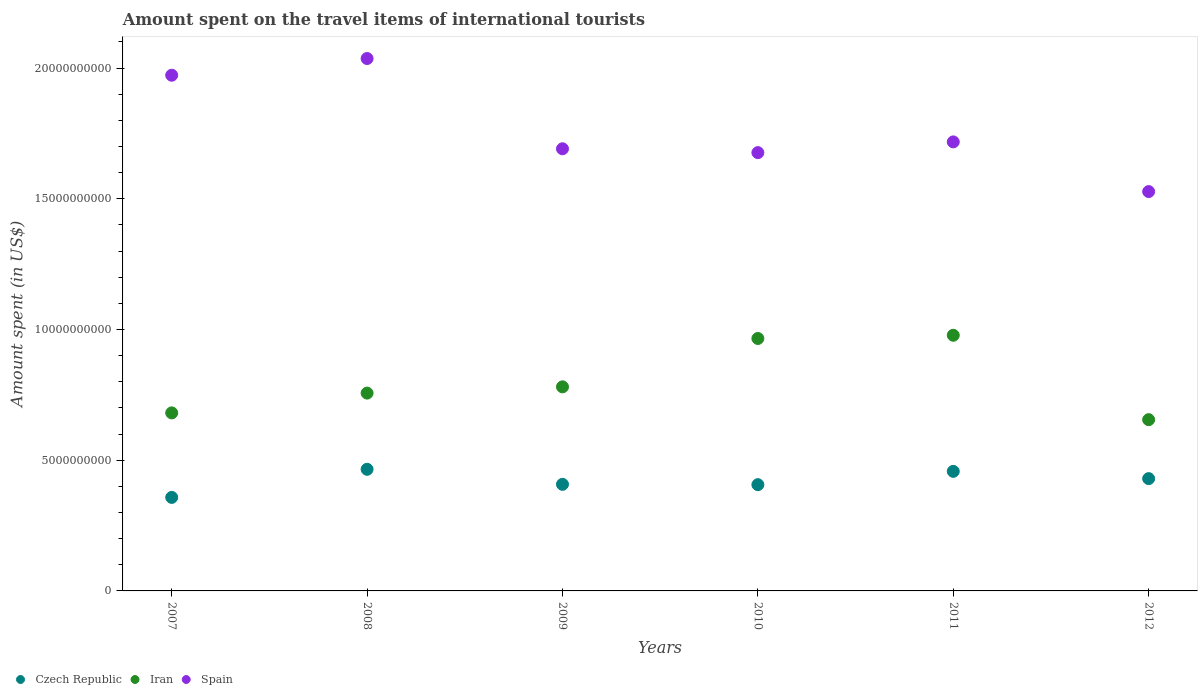Is the number of dotlines equal to the number of legend labels?
Provide a succinct answer. Yes. What is the amount spent on the travel items of international tourists in Iran in 2009?
Provide a succinct answer. 7.80e+09. Across all years, what is the maximum amount spent on the travel items of international tourists in Spain?
Keep it short and to the point. 2.04e+1. Across all years, what is the minimum amount spent on the travel items of international tourists in Spain?
Offer a very short reply. 1.53e+1. What is the total amount spent on the travel items of international tourists in Spain in the graph?
Offer a terse response. 1.06e+11. What is the difference between the amount spent on the travel items of international tourists in Iran in 2009 and that in 2012?
Make the answer very short. 1.26e+09. What is the difference between the amount spent on the travel items of international tourists in Iran in 2009 and the amount spent on the travel items of international tourists in Czech Republic in 2008?
Offer a terse response. 3.15e+09. What is the average amount spent on the travel items of international tourists in Spain per year?
Provide a succinct answer. 1.77e+1. In the year 2011, what is the difference between the amount spent on the travel items of international tourists in Spain and amount spent on the travel items of international tourists in Czech Republic?
Your response must be concise. 1.26e+1. What is the ratio of the amount spent on the travel items of international tourists in Czech Republic in 2009 to that in 2010?
Keep it short and to the point. 1. Is the difference between the amount spent on the travel items of international tourists in Spain in 2007 and 2008 greater than the difference between the amount spent on the travel items of international tourists in Czech Republic in 2007 and 2008?
Your answer should be very brief. Yes. What is the difference between the highest and the second highest amount spent on the travel items of international tourists in Spain?
Provide a short and direct response. 6.39e+08. What is the difference between the highest and the lowest amount spent on the travel items of international tourists in Czech Republic?
Ensure brevity in your answer.  1.08e+09. In how many years, is the amount spent on the travel items of international tourists in Iran greater than the average amount spent on the travel items of international tourists in Iran taken over all years?
Make the answer very short. 2. Is the sum of the amount spent on the travel items of international tourists in Spain in 2009 and 2012 greater than the maximum amount spent on the travel items of international tourists in Iran across all years?
Provide a succinct answer. Yes. Is it the case that in every year, the sum of the amount spent on the travel items of international tourists in Iran and amount spent on the travel items of international tourists in Czech Republic  is greater than the amount spent on the travel items of international tourists in Spain?
Give a very brief answer. No. Does the amount spent on the travel items of international tourists in Spain monotonically increase over the years?
Your answer should be very brief. No. Is the amount spent on the travel items of international tourists in Czech Republic strictly less than the amount spent on the travel items of international tourists in Iran over the years?
Give a very brief answer. Yes. How many dotlines are there?
Give a very brief answer. 3. How many years are there in the graph?
Ensure brevity in your answer.  6. Does the graph contain any zero values?
Give a very brief answer. No. Where does the legend appear in the graph?
Provide a succinct answer. Bottom left. How many legend labels are there?
Your answer should be compact. 3. How are the legend labels stacked?
Offer a terse response. Horizontal. What is the title of the graph?
Your response must be concise. Amount spent on the travel items of international tourists. What is the label or title of the X-axis?
Provide a succinct answer. Years. What is the label or title of the Y-axis?
Keep it short and to the point. Amount spent (in US$). What is the Amount spent (in US$) in Czech Republic in 2007?
Your answer should be very brief. 3.58e+09. What is the Amount spent (in US$) in Iran in 2007?
Provide a short and direct response. 6.81e+09. What is the Amount spent (in US$) of Spain in 2007?
Your answer should be very brief. 1.97e+1. What is the Amount spent (in US$) in Czech Republic in 2008?
Offer a terse response. 4.65e+09. What is the Amount spent (in US$) in Iran in 2008?
Your answer should be compact. 7.57e+09. What is the Amount spent (in US$) in Spain in 2008?
Offer a terse response. 2.04e+1. What is the Amount spent (in US$) in Czech Republic in 2009?
Offer a very short reply. 4.08e+09. What is the Amount spent (in US$) of Iran in 2009?
Offer a very short reply. 7.80e+09. What is the Amount spent (in US$) in Spain in 2009?
Provide a short and direct response. 1.69e+1. What is the Amount spent (in US$) in Czech Republic in 2010?
Offer a very short reply. 4.06e+09. What is the Amount spent (in US$) in Iran in 2010?
Offer a very short reply. 9.66e+09. What is the Amount spent (in US$) in Spain in 2010?
Your response must be concise. 1.68e+1. What is the Amount spent (in US$) of Czech Republic in 2011?
Your response must be concise. 4.57e+09. What is the Amount spent (in US$) in Iran in 2011?
Make the answer very short. 9.78e+09. What is the Amount spent (in US$) in Spain in 2011?
Offer a very short reply. 1.72e+1. What is the Amount spent (in US$) of Czech Republic in 2012?
Give a very brief answer. 4.30e+09. What is the Amount spent (in US$) of Iran in 2012?
Give a very brief answer. 6.55e+09. What is the Amount spent (in US$) in Spain in 2012?
Offer a terse response. 1.53e+1. Across all years, what is the maximum Amount spent (in US$) of Czech Republic?
Offer a very short reply. 4.65e+09. Across all years, what is the maximum Amount spent (in US$) of Iran?
Offer a terse response. 9.78e+09. Across all years, what is the maximum Amount spent (in US$) of Spain?
Provide a short and direct response. 2.04e+1. Across all years, what is the minimum Amount spent (in US$) of Czech Republic?
Your response must be concise. 3.58e+09. Across all years, what is the minimum Amount spent (in US$) of Iran?
Offer a very short reply. 6.55e+09. Across all years, what is the minimum Amount spent (in US$) of Spain?
Your answer should be compact. 1.53e+1. What is the total Amount spent (in US$) of Czech Republic in the graph?
Provide a succinct answer. 2.52e+1. What is the total Amount spent (in US$) of Iran in the graph?
Provide a succinct answer. 4.82e+1. What is the total Amount spent (in US$) of Spain in the graph?
Offer a very short reply. 1.06e+11. What is the difference between the Amount spent (in US$) in Czech Republic in 2007 and that in 2008?
Provide a succinct answer. -1.08e+09. What is the difference between the Amount spent (in US$) in Iran in 2007 and that in 2008?
Your answer should be compact. -7.57e+08. What is the difference between the Amount spent (in US$) of Spain in 2007 and that in 2008?
Offer a very short reply. -6.39e+08. What is the difference between the Amount spent (in US$) of Czech Republic in 2007 and that in 2009?
Provide a short and direct response. -5.00e+08. What is the difference between the Amount spent (in US$) of Iran in 2007 and that in 2009?
Your response must be concise. -9.96e+08. What is the difference between the Amount spent (in US$) of Spain in 2007 and that in 2009?
Give a very brief answer. 2.81e+09. What is the difference between the Amount spent (in US$) of Czech Republic in 2007 and that in 2010?
Your answer should be very brief. -4.87e+08. What is the difference between the Amount spent (in US$) in Iran in 2007 and that in 2010?
Provide a short and direct response. -2.85e+09. What is the difference between the Amount spent (in US$) in Spain in 2007 and that in 2010?
Ensure brevity in your answer.  2.96e+09. What is the difference between the Amount spent (in US$) in Czech Republic in 2007 and that in 2011?
Provide a short and direct response. -9.96e+08. What is the difference between the Amount spent (in US$) of Iran in 2007 and that in 2011?
Keep it short and to the point. -2.97e+09. What is the difference between the Amount spent (in US$) of Spain in 2007 and that in 2011?
Make the answer very short. 2.55e+09. What is the difference between the Amount spent (in US$) of Czech Republic in 2007 and that in 2012?
Provide a short and direct response. -7.18e+08. What is the difference between the Amount spent (in US$) of Iran in 2007 and that in 2012?
Offer a terse response. 2.59e+08. What is the difference between the Amount spent (in US$) of Spain in 2007 and that in 2012?
Keep it short and to the point. 4.45e+09. What is the difference between the Amount spent (in US$) in Czech Republic in 2008 and that in 2009?
Offer a terse response. 5.75e+08. What is the difference between the Amount spent (in US$) in Iran in 2008 and that in 2009?
Your answer should be compact. -2.39e+08. What is the difference between the Amount spent (in US$) in Spain in 2008 and that in 2009?
Offer a terse response. 3.45e+09. What is the difference between the Amount spent (in US$) of Czech Republic in 2008 and that in 2010?
Make the answer very short. 5.88e+08. What is the difference between the Amount spent (in US$) of Iran in 2008 and that in 2010?
Offer a terse response. -2.09e+09. What is the difference between the Amount spent (in US$) in Spain in 2008 and that in 2010?
Provide a short and direct response. 3.60e+09. What is the difference between the Amount spent (in US$) of Czech Republic in 2008 and that in 2011?
Make the answer very short. 7.90e+07. What is the difference between the Amount spent (in US$) in Iran in 2008 and that in 2011?
Give a very brief answer. -2.21e+09. What is the difference between the Amount spent (in US$) of Spain in 2008 and that in 2011?
Give a very brief answer. 3.19e+09. What is the difference between the Amount spent (in US$) in Czech Republic in 2008 and that in 2012?
Provide a short and direct response. 3.57e+08. What is the difference between the Amount spent (in US$) of Iran in 2008 and that in 2012?
Make the answer very short. 1.02e+09. What is the difference between the Amount spent (in US$) of Spain in 2008 and that in 2012?
Your answer should be very brief. 5.09e+09. What is the difference between the Amount spent (in US$) of Czech Republic in 2009 and that in 2010?
Your response must be concise. 1.30e+07. What is the difference between the Amount spent (in US$) in Iran in 2009 and that in 2010?
Your response must be concise. -1.85e+09. What is the difference between the Amount spent (in US$) of Spain in 2009 and that in 2010?
Provide a short and direct response. 1.47e+08. What is the difference between the Amount spent (in US$) of Czech Republic in 2009 and that in 2011?
Keep it short and to the point. -4.96e+08. What is the difference between the Amount spent (in US$) of Iran in 2009 and that in 2011?
Make the answer very short. -1.97e+09. What is the difference between the Amount spent (in US$) in Spain in 2009 and that in 2011?
Provide a short and direct response. -2.63e+08. What is the difference between the Amount spent (in US$) in Czech Republic in 2009 and that in 2012?
Ensure brevity in your answer.  -2.18e+08. What is the difference between the Amount spent (in US$) in Iran in 2009 and that in 2012?
Provide a succinct answer. 1.26e+09. What is the difference between the Amount spent (in US$) in Spain in 2009 and that in 2012?
Your response must be concise. 1.64e+09. What is the difference between the Amount spent (in US$) of Czech Republic in 2010 and that in 2011?
Offer a terse response. -5.09e+08. What is the difference between the Amount spent (in US$) in Iran in 2010 and that in 2011?
Ensure brevity in your answer.  -1.23e+08. What is the difference between the Amount spent (in US$) of Spain in 2010 and that in 2011?
Your answer should be compact. -4.10e+08. What is the difference between the Amount spent (in US$) of Czech Republic in 2010 and that in 2012?
Keep it short and to the point. -2.31e+08. What is the difference between the Amount spent (in US$) of Iran in 2010 and that in 2012?
Give a very brief answer. 3.10e+09. What is the difference between the Amount spent (in US$) in Spain in 2010 and that in 2012?
Ensure brevity in your answer.  1.49e+09. What is the difference between the Amount spent (in US$) of Czech Republic in 2011 and that in 2012?
Make the answer very short. 2.78e+08. What is the difference between the Amount spent (in US$) in Iran in 2011 and that in 2012?
Give a very brief answer. 3.23e+09. What is the difference between the Amount spent (in US$) in Spain in 2011 and that in 2012?
Your answer should be compact. 1.90e+09. What is the difference between the Amount spent (in US$) of Czech Republic in 2007 and the Amount spent (in US$) of Iran in 2008?
Ensure brevity in your answer.  -3.99e+09. What is the difference between the Amount spent (in US$) in Czech Republic in 2007 and the Amount spent (in US$) in Spain in 2008?
Ensure brevity in your answer.  -1.68e+1. What is the difference between the Amount spent (in US$) of Iran in 2007 and the Amount spent (in US$) of Spain in 2008?
Your answer should be very brief. -1.36e+1. What is the difference between the Amount spent (in US$) in Czech Republic in 2007 and the Amount spent (in US$) in Iran in 2009?
Offer a terse response. -4.23e+09. What is the difference between the Amount spent (in US$) of Czech Republic in 2007 and the Amount spent (in US$) of Spain in 2009?
Give a very brief answer. -1.33e+1. What is the difference between the Amount spent (in US$) in Iran in 2007 and the Amount spent (in US$) in Spain in 2009?
Provide a succinct answer. -1.01e+1. What is the difference between the Amount spent (in US$) of Czech Republic in 2007 and the Amount spent (in US$) of Iran in 2010?
Your answer should be compact. -6.08e+09. What is the difference between the Amount spent (in US$) of Czech Republic in 2007 and the Amount spent (in US$) of Spain in 2010?
Your answer should be very brief. -1.32e+1. What is the difference between the Amount spent (in US$) in Iran in 2007 and the Amount spent (in US$) in Spain in 2010?
Ensure brevity in your answer.  -9.96e+09. What is the difference between the Amount spent (in US$) in Czech Republic in 2007 and the Amount spent (in US$) in Iran in 2011?
Offer a terse response. -6.20e+09. What is the difference between the Amount spent (in US$) in Czech Republic in 2007 and the Amount spent (in US$) in Spain in 2011?
Your response must be concise. -1.36e+1. What is the difference between the Amount spent (in US$) of Iran in 2007 and the Amount spent (in US$) of Spain in 2011?
Ensure brevity in your answer.  -1.04e+1. What is the difference between the Amount spent (in US$) in Czech Republic in 2007 and the Amount spent (in US$) in Iran in 2012?
Your answer should be very brief. -2.97e+09. What is the difference between the Amount spent (in US$) of Czech Republic in 2007 and the Amount spent (in US$) of Spain in 2012?
Offer a very short reply. -1.17e+1. What is the difference between the Amount spent (in US$) of Iran in 2007 and the Amount spent (in US$) of Spain in 2012?
Your answer should be very brief. -8.46e+09. What is the difference between the Amount spent (in US$) in Czech Republic in 2008 and the Amount spent (in US$) in Iran in 2009?
Give a very brief answer. -3.15e+09. What is the difference between the Amount spent (in US$) of Czech Republic in 2008 and the Amount spent (in US$) of Spain in 2009?
Your answer should be very brief. -1.23e+1. What is the difference between the Amount spent (in US$) in Iran in 2008 and the Amount spent (in US$) in Spain in 2009?
Provide a short and direct response. -9.34e+09. What is the difference between the Amount spent (in US$) in Czech Republic in 2008 and the Amount spent (in US$) in Iran in 2010?
Your answer should be very brief. -5.00e+09. What is the difference between the Amount spent (in US$) in Czech Republic in 2008 and the Amount spent (in US$) in Spain in 2010?
Your response must be concise. -1.21e+1. What is the difference between the Amount spent (in US$) of Iran in 2008 and the Amount spent (in US$) of Spain in 2010?
Offer a terse response. -9.20e+09. What is the difference between the Amount spent (in US$) in Czech Republic in 2008 and the Amount spent (in US$) in Iran in 2011?
Your response must be concise. -5.13e+09. What is the difference between the Amount spent (in US$) of Czech Republic in 2008 and the Amount spent (in US$) of Spain in 2011?
Offer a very short reply. -1.25e+1. What is the difference between the Amount spent (in US$) of Iran in 2008 and the Amount spent (in US$) of Spain in 2011?
Offer a very short reply. -9.61e+09. What is the difference between the Amount spent (in US$) of Czech Republic in 2008 and the Amount spent (in US$) of Iran in 2012?
Keep it short and to the point. -1.90e+09. What is the difference between the Amount spent (in US$) of Czech Republic in 2008 and the Amount spent (in US$) of Spain in 2012?
Your answer should be compact. -1.06e+1. What is the difference between the Amount spent (in US$) in Iran in 2008 and the Amount spent (in US$) in Spain in 2012?
Offer a terse response. -7.71e+09. What is the difference between the Amount spent (in US$) in Czech Republic in 2009 and the Amount spent (in US$) in Iran in 2010?
Offer a very short reply. -5.58e+09. What is the difference between the Amount spent (in US$) of Czech Republic in 2009 and the Amount spent (in US$) of Spain in 2010?
Your answer should be compact. -1.27e+1. What is the difference between the Amount spent (in US$) in Iran in 2009 and the Amount spent (in US$) in Spain in 2010?
Ensure brevity in your answer.  -8.96e+09. What is the difference between the Amount spent (in US$) of Czech Republic in 2009 and the Amount spent (in US$) of Iran in 2011?
Your answer should be compact. -5.70e+09. What is the difference between the Amount spent (in US$) of Czech Republic in 2009 and the Amount spent (in US$) of Spain in 2011?
Make the answer very short. -1.31e+1. What is the difference between the Amount spent (in US$) in Iran in 2009 and the Amount spent (in US$) in Spain in 2011?
Provide a succinct answer. -9.37e+09. What is the difference between the Amount spent (in US$) in Czech Republic in 2009 and the Amount spent (in US$) in Iran in 2012?
Offer a very short reply. -2.47e+09. What is the difference between the Amount spent (in US$) of Czech Republic in 2009 and the Amount spent (in US$) of Spain in 2012?
Your response must be concise. -1.12e+1. What is the difference between the Amount spent (in US$) of Iran in 2009 and the Amount spent (in US$) of Spain in 2012?
Provide a short and direct response. -7.47e+09. What is the difference between the Amount spent (in US$) of Czech Republic in 2010 and the Amount spent (in US$) of Iran in 2011?
Your response must be concise. -5.71e+09. What is the difference between the Amount spent (in US$) in Czech Republic in 2010 and the Amount spent (in US$) in Spain in 2011?
Make the answer very short. -1.31e+1. What is the difference between the Amount spent (in US$) of Iran in 2010 and the Amount spent (in US$) of Spain in 2011?
Offer a very short reply. -7.52e+09. What is the difference between the Amount spent (in US$) of Czech Republic in 2010 and the Amount spent (in US$) of Iran in 2012?
Your response must be concise. -2.49e+09. What is the difference between the Amount spent (in US$) of Czech Republic in 2010 and the Amount spent (in US$) of Spain in 2012?
Give a very brief answer. -1.12e+1. What is the difference between the Amount spent (in US$) of Iran in 2010 and the Amount spent (in US$) of Spain in 2012?
Your answer should be compact. -5.62e+09. What is the difference between the Amount spent (in US$) in Czech Republic in 2011 and the Amount spent (in US$) in Iran in 2012?
Your answer should be compact. -1.98e+09. What is the difference between the Amount spent (in US$) in Czech Republic in 2011 and the Amount spent (in US$) in Spain in 2012?
Ensure brevity in your answer.  -1.07e+1. What is the difference between the Amount spent (in US$) of Iran in 2011 and the Amount spent (in US$) of Spain in 2012?
Ensure brevity in your answer.  -5.50e+09. What is the average Amount spent (in US$) in Czech Republic per year?
Your answer should be very brief. 4.21e+09. What is the average Amount spent (in US$) of Iran per year?
Keep it short and to the point. 8.03e+09. What is the average Amount spent (in US$) in Spain per year?
Keep it short and to the point. 1.77e+1. In the year 2007, what is the difference between the Amount spent (in US$) of Czech Republic and Amount spent (in US$) of Iran?
Offer a very short reply. -3.23e+09. In the year 2007, what is the difference between the Amount spent (in US$) in Czech Republic and Amount spent (in US$) in Spain?
Give a very brief answer. -1.61e+1. In the year 2007, what is the difference between the Amount spent (in US$) of Iran and Amount spent (in US$) of Spain?
Your response must be concise. -1.29e+1. In the year 2008, what is the difference between the Amount spent (in US$) in Czech Republic and Amount spent (in US$) in Iran?
Ensure brevity in your answer.  -2.91e+09. In the year 2008, what is the difference between the Amount spent (in US$) in Czech Republic and Amount spent (in US$) in Spain?
Provide a short and direct response. -1.57e+1. In the year 2008, what is the difference between the Amount spent (in US$) of Iran and Amount spent (in US$) of Spain?
Provide a succinct answer. -1.28e+1. In the year 2009, what is the difference between the Amount spent (in US$) of Czech Republic and Amount spent (in US$) of Iran?
Offer a very short reply. -3.73e+09. In the year 2009, what is the difference between the Amount spent (in US$) in Czech Republic and Amount spent (in US$) in Spain?
Your answer should be compact. -1.28e+1. In the year 2009, what is the difference between the Amount spent (in US$) of Iran and Amount spent (in US$) of Spain?
Provide a succinct answer. -9.11e+09. In the year 2010, what is the difference between the Amount spent (in US$) in Czech Republic and Amount spent (in US$) in Iran?
Your response must be concise. -5.59e+09. In the year 2010, what is the difference between the Amount spent (in US$) of Czech Republic and Amount spent (in US$) of Spain?
Give a very brief answer. -1.27e+1. In the year 2010, what is the difference between the Amount spent (in US$) of Iran and Amount spent (in US$) of Spain?
Your answer should be very brief. -7.11e+09. In the year 2011, what is the difference between the Amount spent (in US$) in Czech Republic and Amount spent (in US$) in Iran?
Offer a terse response. -5.20e+09. In the year 2011, what is the difference between the Amount spent (in US$) in Czech Republic and Amount spent (in US$) in Spain?
Keep it short and to the point. -1.26e+1. In the year 2011, what is the difference between the Amount spent (in US$) in Iran and Amount spent (in US$) in Spain?
Offer a terse response. -7.40e+09. In the year 2012, what is the difference between the Amount spent (in US$) in Czech Republic and Amount spent (in US$) in Iran?
Your answer should be compact. -2.26e+09. In the year 2012, what is the difference between the Amount spent (in US$) in Czech Republic and Amount spent (in US$) in Spain?
Make the answer very short. -1.10e+1. In the year 2012, what is the difference between the Amount spent (in US$) of Iran and Amount spent (in US$) of Spain?
Give a very brief answer. -8.72e+09. What is the ratio of the Amount spent (in US$) of Czech Republic in 2007 to that in 2008?
Offer a terse response. 0.77. What is the ratio of the Amount spent (in US$) in Iran in 2007 to that in 2008?
Your answer should be very brief. 0.9. What is the ratio of the Amount spent (in US$) of Spain in 2007 to that in 2008?
Ensure brevity in your answer.  0.97. What is the ratio of the Amount spent (in US$) of Czech Republic in 2007 to that in 2009?
Keep it short and to the point. 0.88. What is the ratio of the Amount spent (in US$) in Iran in 2007 to that in 2009?
Offer a very short reply. 0.87. What is the ratio of the Amount spent (in US$) of Spain in 2007 to that in 2009?
Give a very brief answer. 1.17. What is the ratio of the Amount spent (in US$) of Czech Republic in 2007 to that in 2010?
Offer a terse response. 0.88. What is the ratio of the Amount spent (in US$) in Iran in 2007 to that in 2010?
Give a very brief answer. 0.71. What is the ratio of the Amount spent (in US$) of Spain in 2007 to that in 2010?
Provide a succinct answer. 1.18. What is the ratio of the Amount spent (in US$) in Czech Republic in 2007 to that in 2011?
Provide a short and direct response. 0.78. What is the ratio of the Amount spent (in US$) in Iran in 2007 to that in 2011?
Your answer should be compact. 0.7. What is the ratio of the Amount spent (in US$) in Spain in 2007 to that in 2011?
Give a very brief answer. 1.15. What is the ratio of the Amount spent (in US$) in Czech Republic in 2007 to that in 2012?
Ensure brevity in your answer.  0.83. What is the ratio of the Amount spent (in US$) of Iran in 2007 to that in 2012?
Offer a terse response. 1.04. What is the ratio of the Amount spent (in US$) of Spain in 2007 to that in 2012?
Your response must be concise. 1.29. What is the ratio of the Amount spent (in US$) of Czech Republic in 2008 to that in 2009?
Your answer should be compact. 1.14. What is the ratio of the Amount spent (in US$) of Iran in 2008 to that in 2009?
Give a very brief answer. 0.97. What is the ratio of the Amount spent (in US$) in Spain in 2008 to that in 2009?
Offer a terse response. 1.2. What is the ratio of the Amount spent (in US$) of Czech Republic in 2008 to that in 2010?
Ensure brevity in your answer.  1.14. What is the ratio of the Amount spent (in US$) in Iran in 2008 to that in 2010?
Ensure brevity in your answer.  0.78. What is the ratio of the Amount spent (in US$) of Spain in 2008 to that in 2010?
Offer a terse response. 1.21. What is the ratio of the Amount spent (in US$) of Czech Republic in 2008 to that in 2011?
Provide a short and direct response. 1.02. What is the ratio of the Amount spent (in US$) of Iran in 2008 to that in 2011?
Provide a short and direct response. 0.77. What is the ratio of the Amount spent (in US$) of Spain in 2008 to that in 2011?
Your response must be concise. 1.19. What is the ratio of the Amount spent (in US$) of Czech Republic in 2008 to that in 2012?
Provide a succinct answer. 1.08. What is the ratio of the Amount spent (in US$) of Iran in 2008 to that in 2012?
Offer a very short reply. 1.16. What is the ratio of the Amount spent (in US$) of Spain in 2008 to that in 2012?
Keep it short and to the point. 1.33. What is the ratio of the Amount spent (in US$) of Czech Republic in 2009 to that in 2010?
Offer a very short reply. 1. What is the ratio of the Amount spent (in US$) in Iran in 2009 to that in 2010?
Your answer should be very brief. 0.81. What is the ratio of the Amount spent (in US$) in Spain in 2009 to that in 2010?
Ensure brevity in your answer.  1.01. What is the ratio of the Amount spent (in US$) in Czech Republic in 2009 to that in 2011?
Your response must be concise. 0.89. What is the ratio of the Amount spent (in US$) of Iran in 2009 to that in 2011?
Make the answer very short. 0.8. What is the ratio of the Amount spent (in US$) of Spain in 2009 to that in 2011?
Provide a short and direct response. 0.98. What is the ratio of the Amount spent (in US$) in Czech Republic in 2009 to that in 2012?
Keep it short and to the point. 0.95. What is the ratio of the Amount spent (in US$) in Iran in 2009 to that in 2012?
Your answer should be very brief. 1.19. What is the ratio of the Amount spent (in US$) in Spain in 2009 to that in 2012?
Provide a short and direct response. 1.11. What is the ratio of the Amount spent (in US$) of Czech Republic in 2010 to that in 2011?
Your answer should be very brief. 0.89. What is the ratio of the Amount spent (in US$) of Iran in 2010 to that in 2011?
Offer a terse response. 0.99. What is the ratio of the Amount spent (in US$) of Spain in 2010 to that in 2011?
Ensure brevity in your answer.  0.98. What is the ratio of the Amount spent (in US$) in Czech Republic in 2010 to that in 2012?
Provide a succinct answer. 0.95. What is the ratio of the Amount spent (in US$) in Iran in 2010 to that in 2012?
Make the answer very short. 1.47. What is the ratio of the Amount spent (in US$) of Spain in 2010 to that in 2012?
Your answer should be compact. 1.1. What is the ratio of the Amount spent (in US$) in Czech Republic in 2011 to that in 2012?
Keep it short and to the point. 1.06. What is the ratio of the Amount spent (in US$) of Iran in 2011 to that in 2012?
Provide a short and direct response. 1.49. What is the ratio of the Amount spent (in US$) of Spain in 2011 to that in 2012?
Your answer should be compact. 1.12. What is the difference between the highest and the second highest Amount spent (in US$) of Czech Republic?
Provide a succinct answer. 7.90e+07. What is the difference between the highest and the second highest Amount spent (in US$) in Iran?
Ensure brevity in your answer.  1.23e+08. What is the difference between the highest and the second highest Amount spent (in US$) of Spain?
Your answer should be compact. 6.39e+08. What is the difference between the highest and the lowest Amount spent (in US$) of Czech Republic?
Keep it short and to the point. 1.08e+09. What is the difference between the highest and the lowest Amount spent (in US$) in Iran?
Provide a succinct answer. 3.23e+09. What is the difference between the highest and the lowest Amount spent (in US$) in Spain?
Keep it short and to the point. 5.09e+09. 